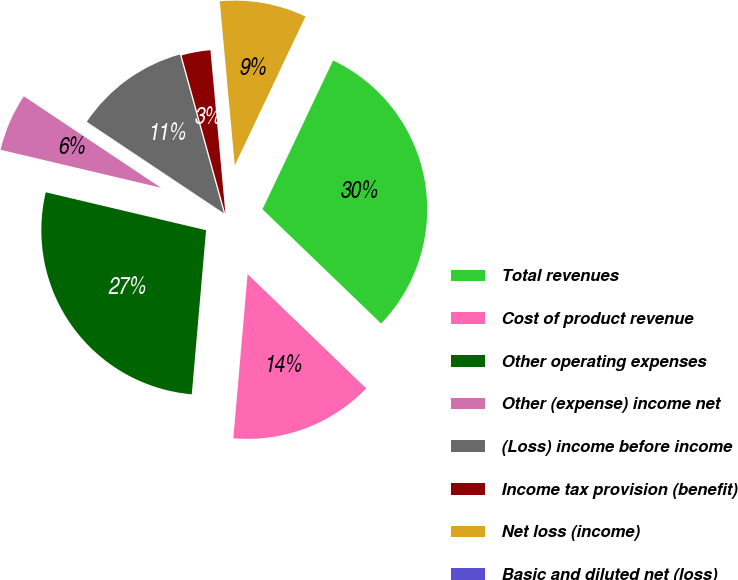Convert chart to OTSL. <chart><loc_0><loc_0><loc_500><loc_500><pie_chart><fcel>Total revenues<fcel>Cost of product revenue<fcel>Other operating expenses<fcel>Other (expense) income net<fcel>(Loss) income before income<fcel>Income tax provision (benefit)<fcel>Net loss (income)<fcel>Basic and diluted net (loss)<nl><fcel>30.15%<fcel>14.18%<fcel>27.32%<fcel>5.67%<fcel>11.34%<fcel>2.84%<fcel>8.51%<fcel>0.0%<nl></chart> 